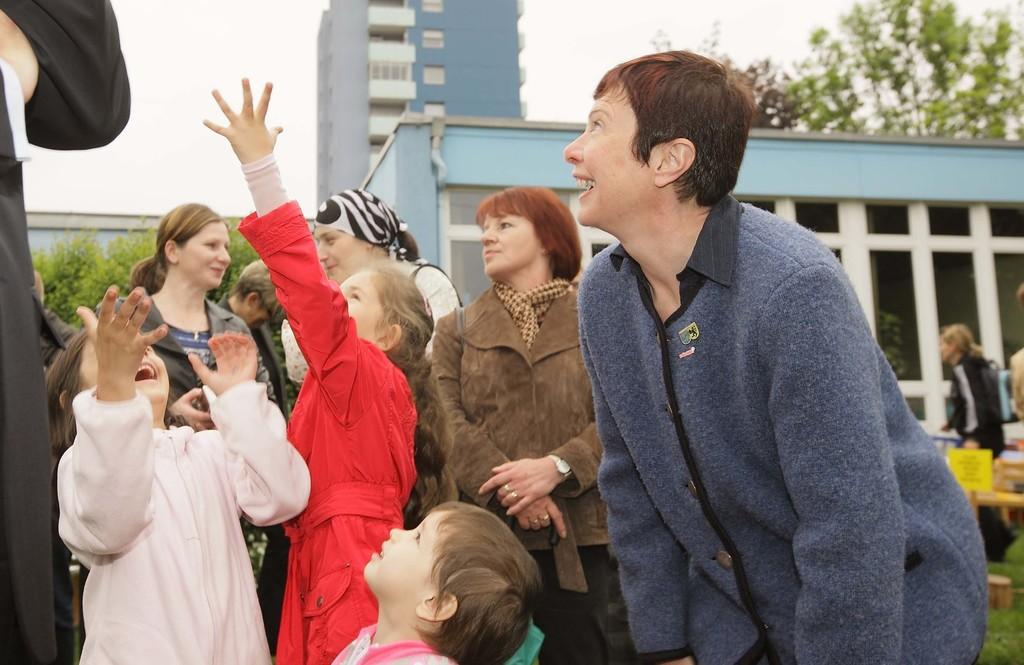What can be seen in the image regarding the people? There are people wearing clothes in the image. What is the main structure in the middle of the image? There is a building in the middle of the image. What type of vegetation is on the left side of the image? There is a tree on the left side of the image. Where is another tree located in the image? There is a tree in the top right corner of the image. What type of wool is being used to make the fog in the image? There is no fog or wool present in the image. 